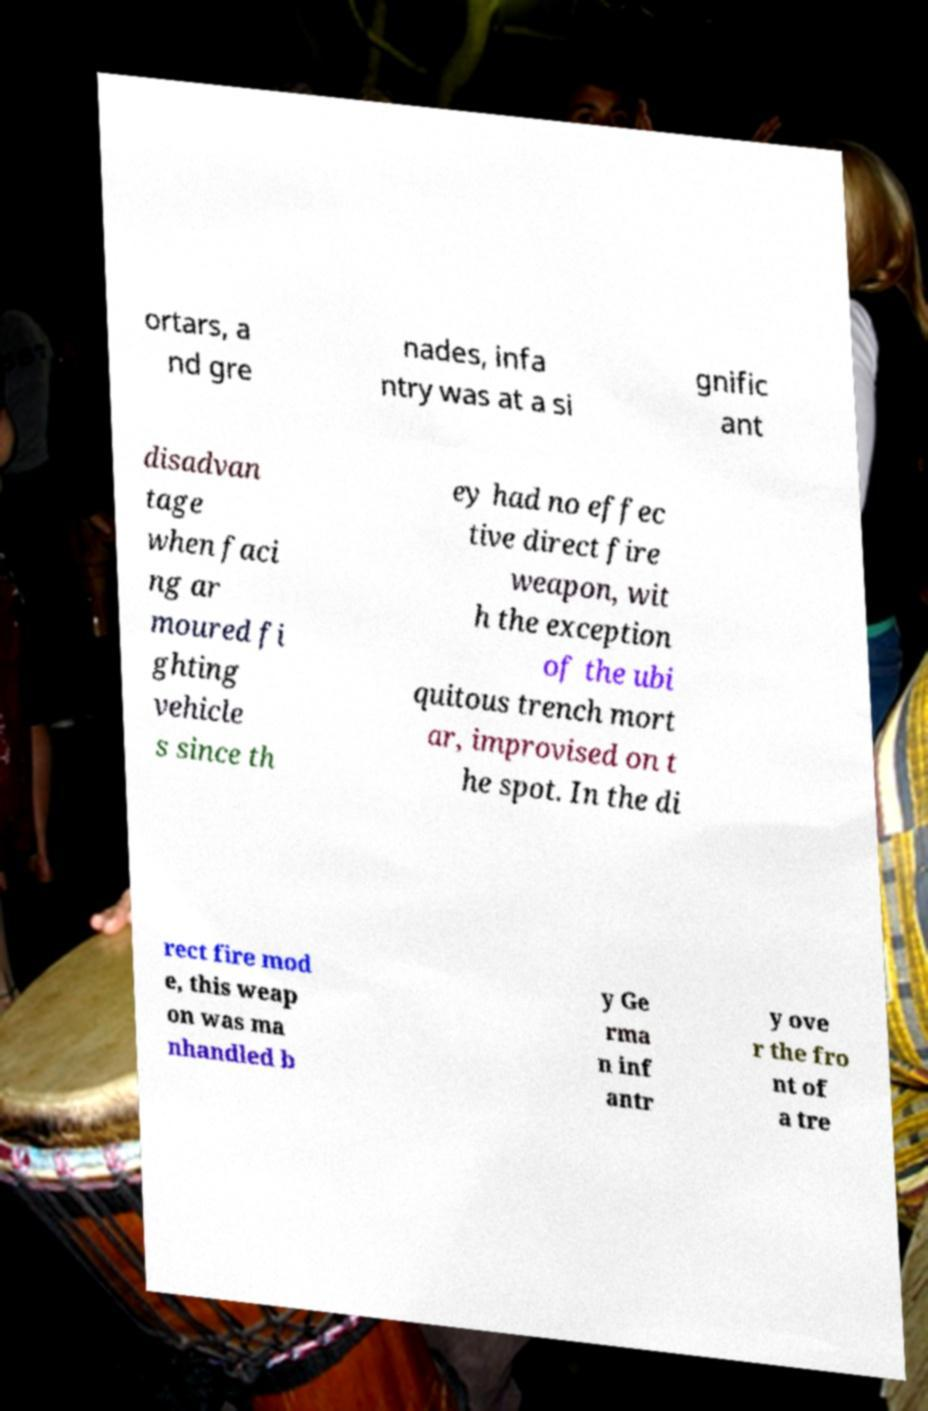Please identify and transcribe the text found in this image. ortars, a nd gre nades, infa ntry was at a si gnific ant disadvan tage when faci ng ar moured fi ghting vehicle s since th ey had no effec tive direct fire weapon, wit h the exception of the ubi quitous trench mort ar, improvised on t he spot. In the di rect fire mod e, this weap on was ma nhandled b y Ge rma n inf antr y ove r the fro nt of a tre 